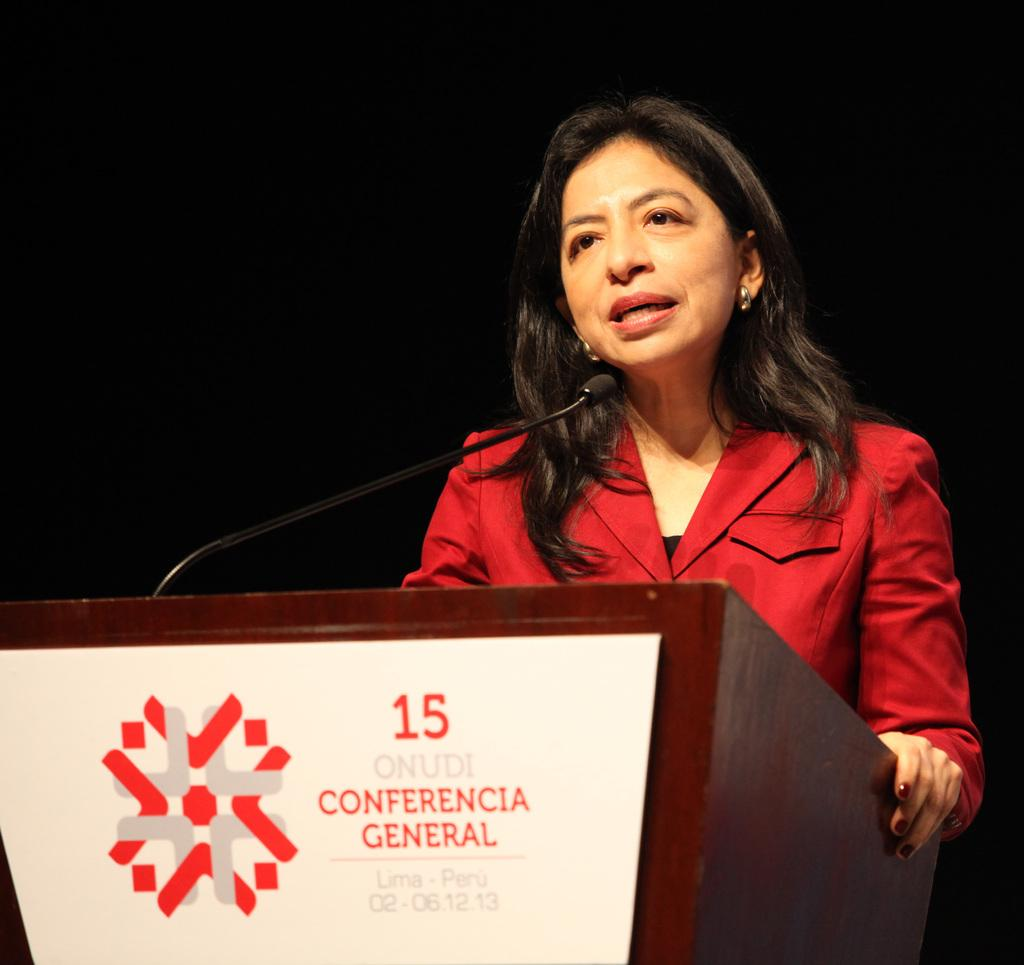What object is the main focus of the image? There is a microphone (mic) in the image. What else can be seen in the image besides the microphone? There is a banner in the image. Can you describe the woman in the image? There is a woman wearing a red jacket in the image. What is the color of the background in the image? The background of the image is dark. What type of art is displayed on the banner in the image? There is no art displayed on the banner in the image; it is not mentioned in the provided facts. 